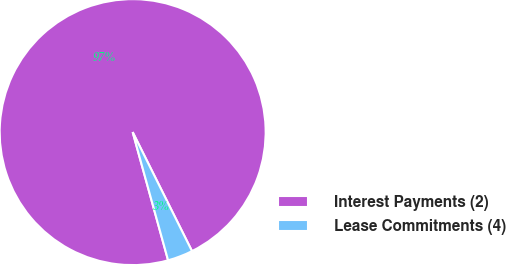Convert chart to OTSL. <chart><loc_0><loc_0><loc_500><loc_500><pie_chart><fcel>Interest Payments (2)<fcel>Lease Commitments (4)<nl><fcel>96.93%<fcel>3.07%<nl></chart> 